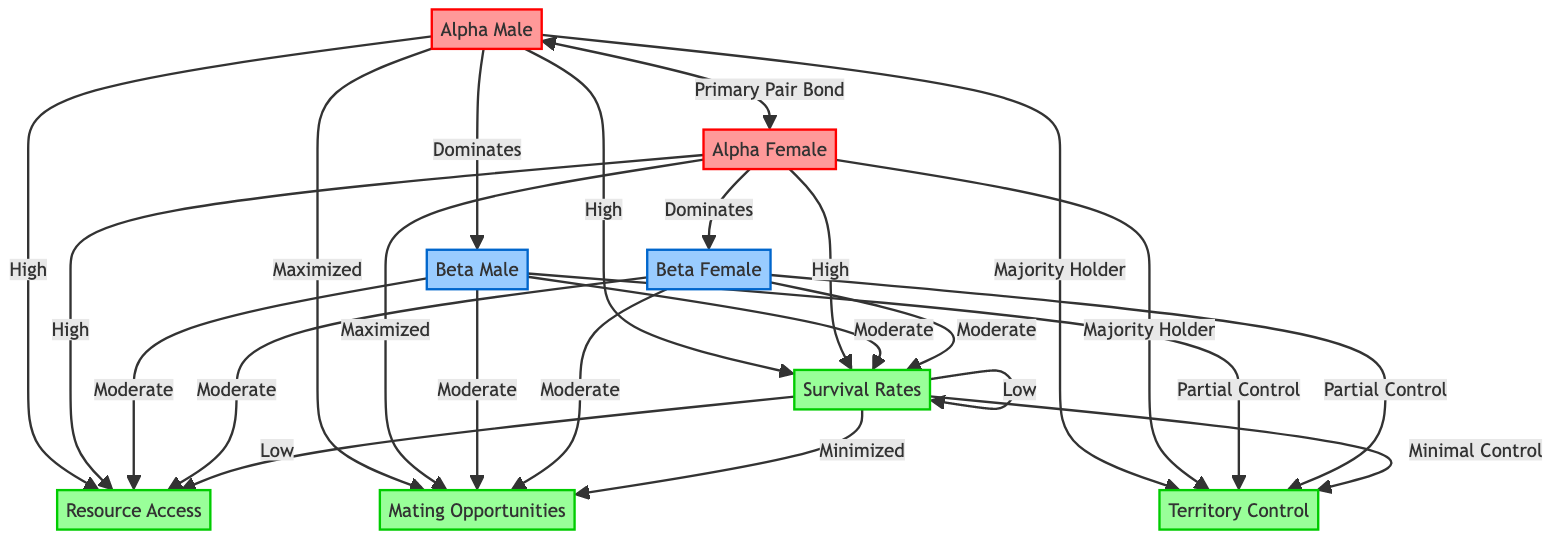What is the primary pair bond in this diagram? The diagram indicates that the primary pair bond is between the Alpha Male and Alpha Female, as shown by the directed arrow labeled "Primary Pair Bond" connecting the two.
Answer: Alpha Male and Alpha Female How many types of raptors are represented in the diagram? The diagram shows three types of raptors: Alpha, Beta, and Subordinate, reflected in the nodes labeled Alpha Male, Alpha Female, Beta Male, Beta Female, and Subordinate Raptors.
Answer: Three Which raptors have high resource access? The diagram illustrates that the Alpha Male and Alpha Female have high resource access, as indicated by the arrows pointing from them to the Resource Access node labeled "High."
Answer: Alpha Male and Alpha Female Which group has minimal control over territory? According to the diagram, the Subordinate Raptors have minimal control over territory, as shown by the label "Minimal Control" pointing to the Territory Control node.
Answer: Subordinate Raptors What is the mating opportunity status of subordinate raptors? The diagram explicitly states that Subordinate Raptors are assigned "Minimized" mating opportunities, as signified by the arrow leading from Subordinate Raptors to Mating Opportunities showing this status.
Answer: Minimized How does the survival rate for subordinate raptors compare to alpha raptors? The diagram shows that the survival rates for subordinate raptors are low, while those for alpha raptors (both Male and Female) are high, indicating a significant difference in survival based on hierarchy.
Answer: Low and High Which raptors have partial control over territory? The diagram highlights that both Beta Male and Beta Female have partial control over territory, indicated by the label "Partial Control" pointing to Territory Control.
Answer: Beta Male and Beta Female What term describes the opportunity for mating for alpha raptors? The diagram indicates that alpha raptors have "Maximized" mating opportunities, as depicted by arrows leading from Alpha Male and Alpha Female to the Mating Opportunities node.
Answer: Maximized How do beta raptors' resource access compare to subordinate raptors? The diagram outlines that Beta Male and Beta Female have moderate resource access, contrasting with the subordinate raptors who have low resource access, therefore demonstrating a significant hierarchical advantage.
Answer: Moderate and Low 